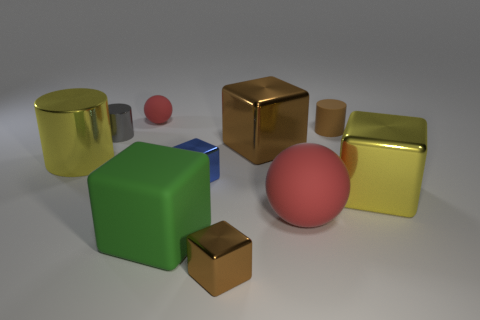What is the size of the blue metallic thing?
Make the answer very short. Small. Are there the same number of yellow objects on the left side of the gray thing and gray metal blocks?
Your answer should be compact. No. How many other objects are the same color as the large rubber ball?
Provide a succinct answer. 1. There is a thing that is behind the big brown object and right of the blue metallic object; what is its color?
Offer a terse response. Brown. There is a ball that is left of the brown block behind the yellow object that is on the right side of the green rubber block; what size is it?
Provide a succinct answer. Small. What number of things are red matte balls right of the tiny red rubber ball or red objects that are in front of the small blue metal thing?
Make the answer very short. 1. What shape is the green matte thing?
Keep it short and to the point. Cube. What number of other things are there of the same material as the big cylinder
Make the answer very short. 5. The other shiny object that is the same shape as the small gray object is what size?
Offer a terse response. Large. What is the material of the sphere that is behind the large yellow metallic object on the right side of the tiny metallic object that is in front of the green object?
Ensure brevity in your answer.  Rubber. 